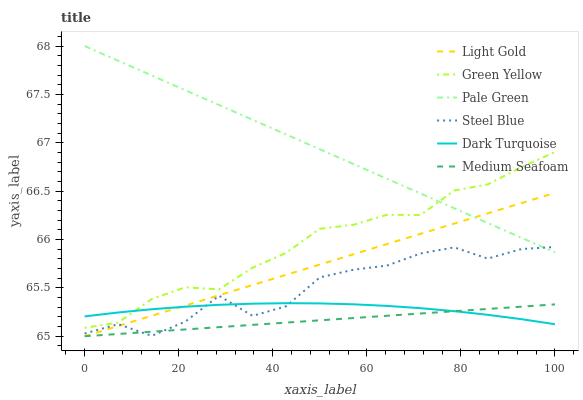Does Medium Seafoam have the minimum area under the curve?
Answer yes or no. Yes. Does Pale Green have the maximum area under the curve?
Answer yes or no. Yes. Does Steel Blue have the minimum area under the curve?
Answer yes or no. No. Does Steel Blue have the maximum area under the curve?
Answer yes or no. No. Is Light Gold the smoothest?
Answer yes or no. Yes. Is Steel Blue the roughest?
Answer yes or no. Yes. Is Pale Green the smoothest?
Answer yes or no. No. Is Pale Green the roughest?
Answer yes or no. No. Does Light Gold have the lowest value?
Answer yes or no. Yes. Does Steel Blue have the lowest value?
Answer yes or no. No. Does Pale Green have the highest value?
Answer yes or no. Yes. Does Steel Blue have the highest value?
Answer yes or no. No. Is Medium Seafoam less than Green Yellow?
Answer yes or no. Yes. Is Green Yellow greater than Light Gold?
Answer yes or no. Yes. Does Light Gold intersect Pale Green?
Answer yes or no. Yes. Is Light Gold less than Pale Green?
Answer yes or no. No. Is Light Gold greater than Pale Green?
Answer yes or no. No. Does Medium Seafoam intersect Green Yellow?
Answer yes or no. No. 